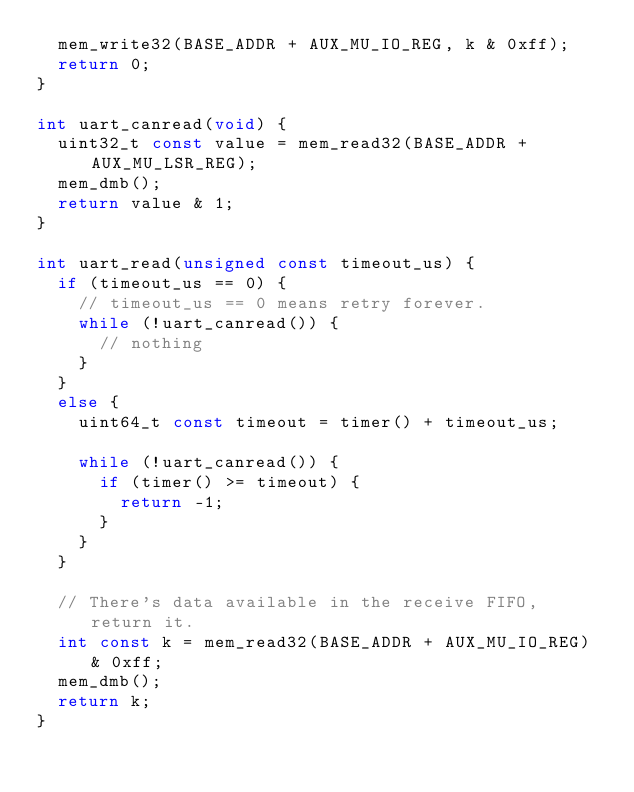Convert code to text. <code><loc_0><loc_0><loc_500><loc_500><_C_>  mem_write32(BASE_ADDR + AUX_MU_IO_REG, k & 0xff);
  return 0;
}

int uart_canread(void) {
  uint32_t const value = mem_read32(BASE_ADDR + AUX_MU_LSR_REG);
  mem_dmb();
  return value & 1;
}

int uart_read(unsigned const timeout_us) {
  if (timeout_us == 0) {
    // timeout_us == 0 means retry forever.
    while (!uart_canread()) {
      // nothing
    }
  }
  else {
    uint64_t const timeout = timer() + timeout_us;

    while (!uart_canread()) {
      if (timer() >= timeout) {
        return -1;
      }
    }
  }

  // There's data available in the receive FIFO, return it.
  int const k = mem_read32(BASE_ADDR + AUX_MU_IO_REG) & 0xff;
  mem_dmb();
  return k;
}
</code> 